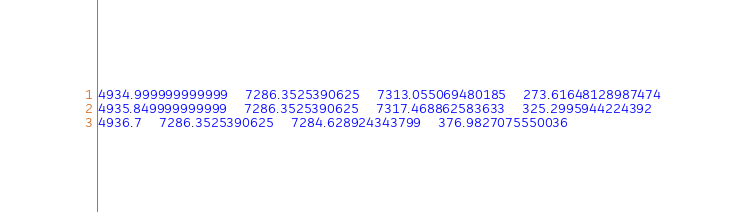Convert code to text. <code><loc_0><loc_0><loc_500><loc_500><_SQL_>4934.999999999999	7286.3525390625	7313.055069480185	273.61648128987474
4935.849999999999	7286.3525390625	7317.468862583633	325.2995944224392
4936.7	7286.3525390625	7284.628924343799	376.9827075550036</code> 